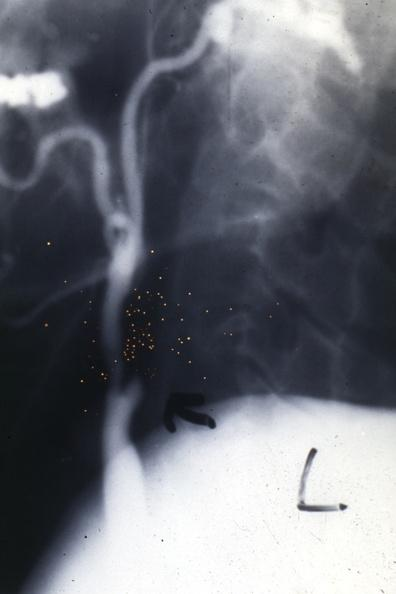s mitotic figures present?
Answer the question using a single word or phrase. No 